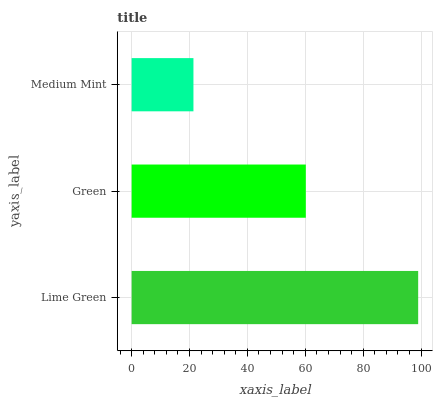Is Medium Mint the minimum?
Answer yes or no. Yes. Is Lime Green the maximum?
Answer yes or no. Yes. Is Green the minimum?
Answer yes or no. No. Is Green the maximum?
Answer yes or no. No. Is Lime Green greater than Green?
Answer yes or no. Yes. Is Green less than Lime Green?
Answer yes or no. Yes. Is Green greater than Lime Green?
Answer yes or no. No. Is Lime Green less than Green?
Answer yes or no. No. Is Green the high median?
Answer yes or no. Yes. Is Green the low median?
Answer yes or no. Yes. Is Medium Mint the high median?
Answer yes or no. No. Is Lime Green the low median?
Answer yes or no. No. 